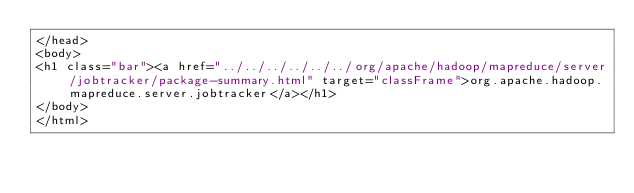<code> <loc_0><loc_0><loc_500><loc_500><_HTML_></head>
<body>
<h1 class="bar"><a href="../../../../../../org/apache/hadoop/mapreduce/server/jobtracker/package-summary.html" target="classFrame">org.apache.hadoop.mapreduce.server.jobtracker</a></h1>
</body>
</html>
</code> 